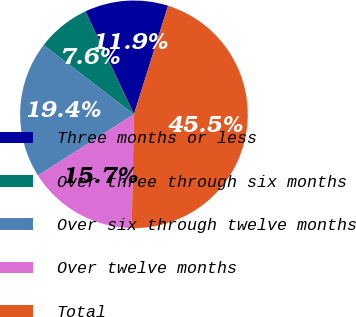Convert chart. <chart><loc_0><loc_0><loc_500><loc_500><pie_chart><fcel>Three months or less<fcel>Over three through six months<fcel>Over six through twelve months<fcel>Over twelve months<fcel>Total<nl><fcel>11.87%<fcel>7.57%<fcel>19.44%<fcel>15.65%<fcel>45.46%<nl></chart> 